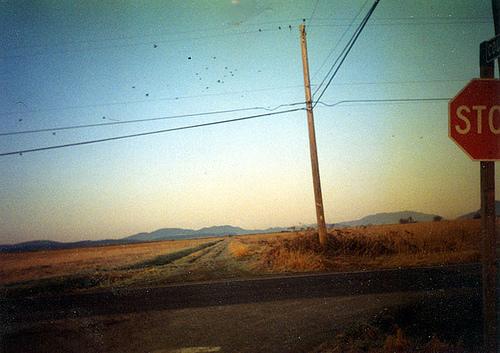Was is the color of the stop sign?
Give a very brief answer. Red. Is this a country lane?
Keep it brief. Yes. Is there a house on the picture?
Give a very brief answer. No. How many different directions to the electrical lines go?
Keep it brief. 3. Is this taken on a sunny day?
Short answer required. Yes. Is there a crosswalk in the photo?
Write a very short answer. No. How many building?
Write a very short answer. 0. What is the sign saying?
Short answer required. Stop. Is this stop sign homemade?
Keep it brief. No. What does the pizza sign say?
Write a very short answer. Stop. Is there daylight in the picture?
Keep it brief. Yes. What is in the distance?
Short answer required. Mountains. 